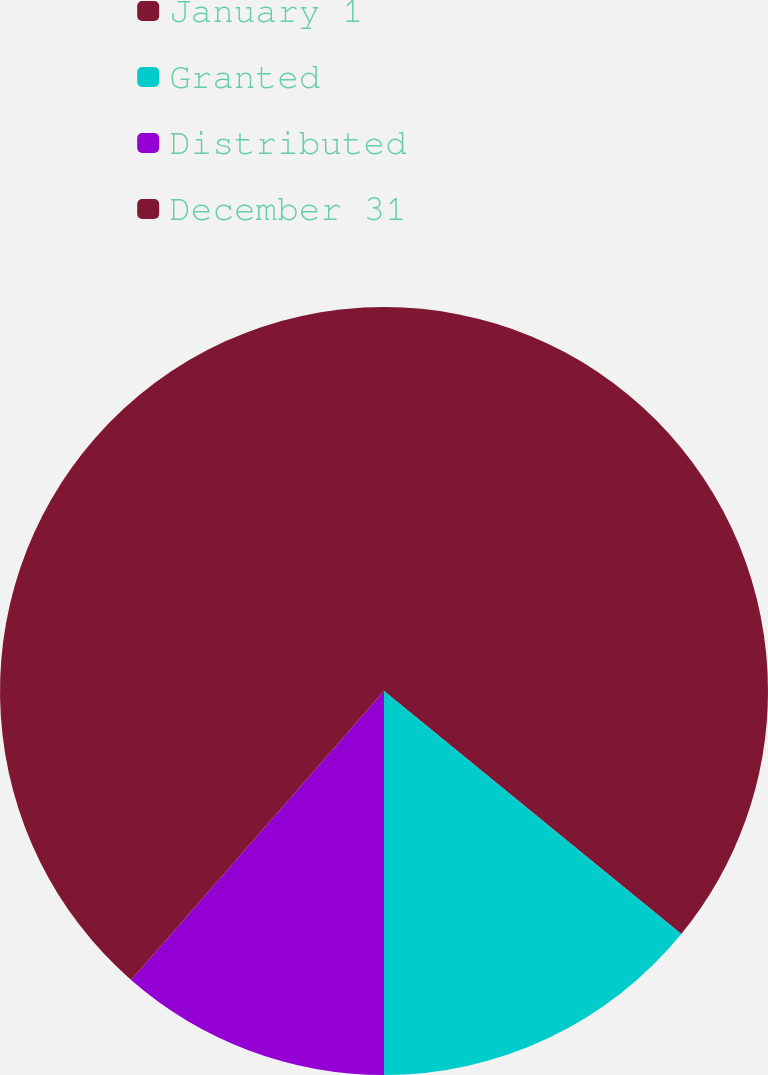Convert chart. <chart><loc_0><loc_0><loc_500><loc_500><pie_chart><fcel>January 1<fcel>Granted<fcel>Distributed<fcel>December 31<nl><fcel>35.91%<fcel>14.09%<fcel>11.44%<fcel>38.56%<nl></chart> 